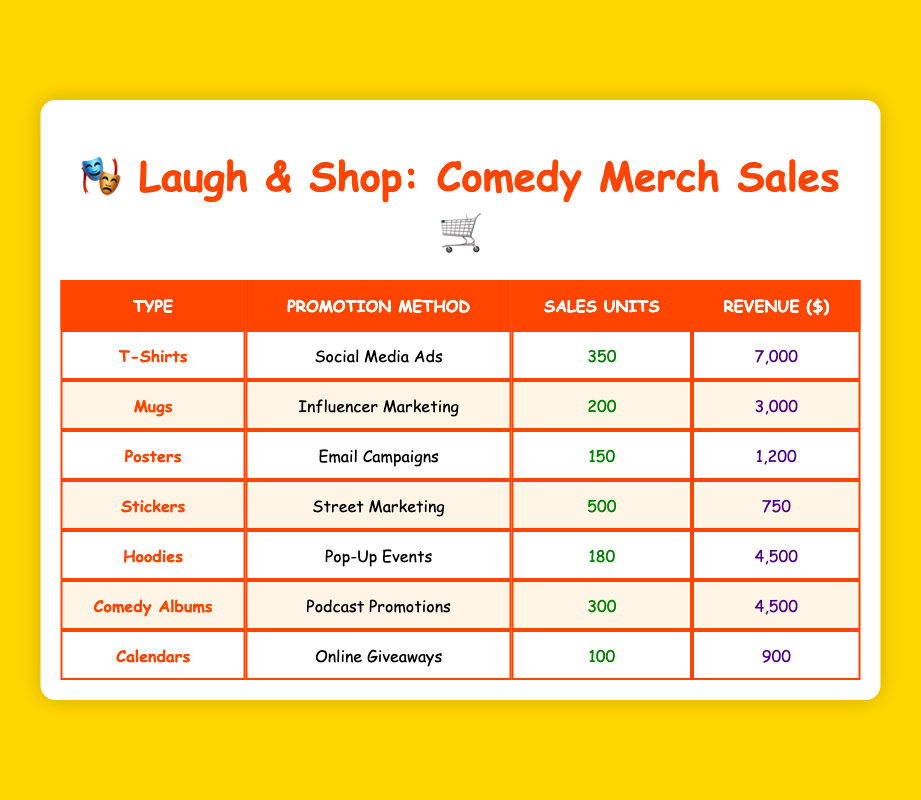What is the total revenue generated from T-Shirts? The revenue for T-Shirts is listed in the table as $7,000. Therefore, the total revenue generated from T-Shirts is simply the value presented in that row.
Answer: 7000 How many units of Hoodies were sold? The table shows that 180 units of Hoodies were sold, which is directly read from the specified row.
Answer: 180 What is the combined revenue from Comedy Albums and Mugs? The revenue for Comedy Albums is $4,500 and for Mugs is $3,000. Combining these two revenues gives us $4,500 + $3,000 = $7,500.
Answer: 7500 Is it true that more Stickers were sold than Posters? The table indicates that 500 units of Stickers were sold while only 150 units of Posters were sold. Since 500 is greater than 150, the statement is indeed true.
Answer: True What is the average number of sales units across all merchandise types? To find the average, we first add the sales units: 350 (T-Shirts) + 200 (Mugs) + 150 (Posters) + 500 (Stickers) + 180 (Hoodies) + 300 (Comedy Albums) + 100 (Calendars) = 1,780. There are 7 types of merchandise, so the average is 1,780 / 7 ≈ 254.29 units.
Answer: Approximately 254.29 Which promotion method generated the least revenue? The revenues for all promotion methods are: Social Media Ads ($7,000), Influencer Marketing ($3,000), Email Campaigns ($1,200), Street Marketing ($750), Pop-Up Events ($4,500), Podcast Promotions ($4,500), and Online Giveaways ($900). The method with the least revenue is Street Marketing, which generated $750.
Answer: Street Marketing What is the total number of sales units for all merchandise types combined? To find the total, we combine the sales units of each type: 350 (T-Shirts) + 200 (Mugs) + 150 (Posters) + 500 (Stickers) + 180 (Hoodies) + 300 (Comedy Albums) + 100 (Calendars) = 1,780. Therefore, the total is 1,780 units sold across all merchandise types.
Answer: 1780 